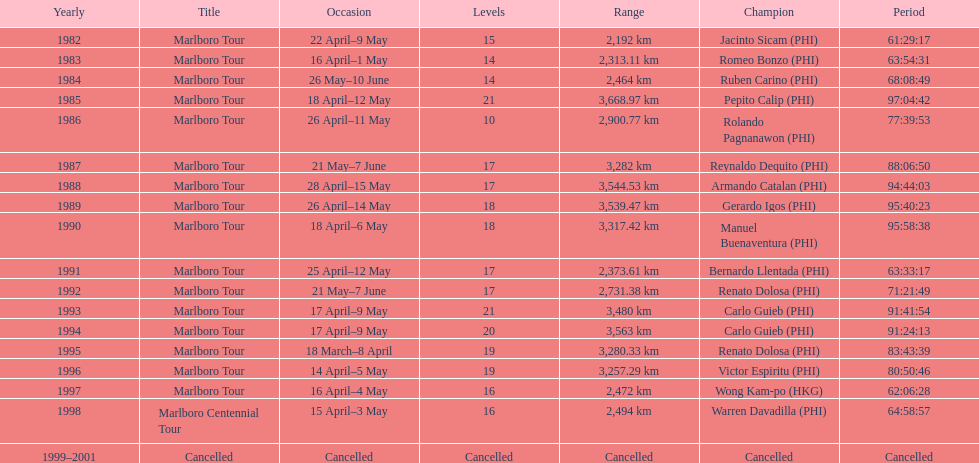Write the full table. {'header': ['Yearly', 'Title', 'Occasion', 'Levels', 'Range', 'Champion', 'Period'], 'rows': [['1982', 'Marlboro Tour', '22 April–9 May', '15', '2,192\xa0km', 'Jacinto Sicam\xa0(PHI)', '61:29:17'], ['1983', 'Marlboro Tour', '16 April–1 May', '14', '2,313.11\xa0km', 'Romeo Bonzo\xa0(PHI)', '63:54:31'], ['1984', 'Marlboro Tour', '26 May–10 June', '14', '2,464\xa0km', 'Ruben Carino\xa0(PHI)', '68:08:49'], ['1985', 'Marlboro Tour', '18 April–12 May', '21', '3,668.97\xa0km', 'Pepito Calip\xa0(PHI)', '97:04:42'], ['1986', 'Marlboro Tour', '26 April–11 May', '10', '2,900.77\xa0km', 'Rolando Pagnanawon\xa0(PHI)', '77:39:53'], ['1987', 'Marlboro Tour', '21 May–7 June', '17', '3,282\xa0km', 'Reynaldo Dequito\xa0(PHI)', '88:06:50'], ['1988', 'Marlboro Tour', '28 April–15 May', '17', '3,544.53\xa0km', 'Armando Catalan\xa0(PHI)', '94:44:03'], ['1989', 'Marlboro Tour', '26 April–14 May', '18', '3,539.47\xa0km', 'Gerardo Igos\xa0(PHI)', '95:40:23'], ['1990', 'Marlboro Tour', '18 April–6 May', '18', '3,317.42\xa0km', 'Manuel Buenaventura\xa0(PHI)', '95:58:38'], ['1991', 'Marlboro Tour', '25 April–12 May', '17', '2,373.61\xa0km', 'Bernardo Llentada\xa0(PHI)', '63:33:17'], ['1992', 'Marlboro Tour', '21 May–7 June', '17', '2,731.38\xa0km', 'Renato Dolosa\xa0(PHI)', '71:21:49'], ['1993', 'Marlboro Tour', '17 April–9 May', '21', '3,480\xa0km', 'Carlo Guieb\xa0(PHI)', '91:41:54'], ['1994', 'Marlboro Tour', '17 April–9 May', '20', '3,563\xa0km', 'Carlo Guieb\xa0(PHI)', '91:24:13'], ['1995', 'Marlboro Tour', '18 March–8 April', '19', '3,280.33\xa0km', 'Renato Dolosa\xa0(PHI)', '83:43:39'], ['1996', 'Marlboro Tour', '14 April–5 May', '19', '3,257.29\xa0km', 'Victor Espiritu\xa0(PHI)', '80:50:46'], ['1997', 'Marlboro Tour', '16 April–4 May', '16', '2,472\xa0km', 'Wong Kam-po\xa0(HKG)', '62:06:28'], ['1998', 'Marlboro Centennial Tour', '15 April–3 May', '16', '2,494\xa0km', 'Warren Davadilla\xa0(PHI)', '64:58:57'], ['1999–2001', 'Cancelled', 'Cancelled', 'Cancelled', 'Cancelled', 'Cancelled', 'Cancelled']]} Who is listed below romeo bonzo? Ruben Carino (PHI). 